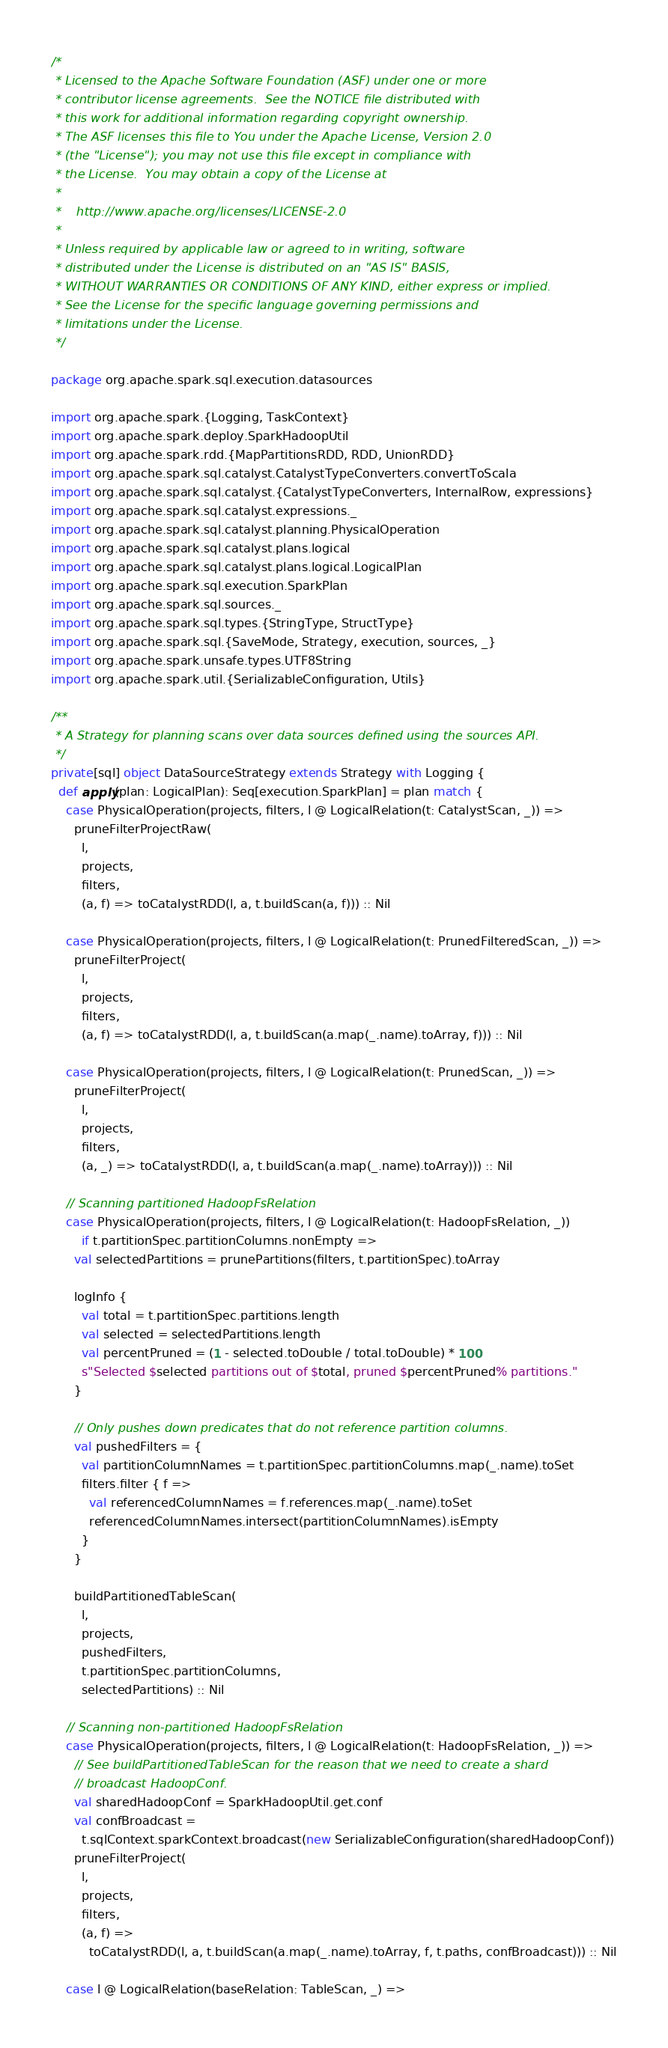<code> <loc_0><loc_0><loc_500><loc_500><_Scala_>/*
 * Licensed to the Apache Software Foundation (ASF) under one or more
 * contributor license agreements.  See the NOTICE file distributed with
 * this work for additional information regarding copyright ownership.
 * The ASF licenses this file to You under the Apache License, Version 2.0
 * (the "License"); you may not use this file except in compliance with
 * the License.  You may obtain a copy of the License at
 *
 *    http://www.apache.org/licenses/LICENSE-2.0
 *
 * Unless required by applicable law or agreed to in writing, software
 * distributed under the License is distributed on an "AS IS" BASIS,
 * WITHOUT WARRANTIES OR CONDITIONS OF ANY KIND, either express or implied.
 * See the License for the specific language governing permissions and
 * limitations under the License.
 */

package org.apache.spark.sql.execution.datasources

import org.apache.spark.{Logging, TaskContext}
import org.apache.spark.deploy.SparkHadoopUtil
import org.apache.spark.rdd.{MapPartitionsRDD, RDD, UnionRDD}
import org.apache.spark.sql.catalyst.CatalystTypeConverters.convertToScala
import org.apache.spark.sql.catalyst.{CatalystTypeConverters, InternalRow, expressions}
import org.apache.spark.sql.catalyst.expressions._
import org.apache.spark.sql.catalyst.planning.PhysicalOperation
import org.apache.spark.sql.catalyst.plans.logical
import org.apache.spark.sql.catalyst.plans.logical.LogicalPlan
import org.apache.spark.sql.execution.SparkPlan
import org.apache.spark.sql.sources._
import org.apache.spark.sql.types.{StringType, StructType}
import org.apache.spark.sql.{SaveMode, Strategy, execution, sources, _}
import org.apache.spark.unsafe.types.UTF8String
import org.apache.spark.util.{SerializableConfiguration, Utils}

/**
 * A Strategy for planning scans over data sources defined using the sources API.
 */
private[sql] object DataSourceStrategy extends Strategy with Logging {
  def apply(plan: LogicalPlan): Seq[execution.SparkPlan] = plan match {
    case PhysicalOperation(projects, filters, l @ LogicalRelation(t: CatalystScan, _)) =>
      pruneFilterProjectRaw(
        l,
        projects,
        filters,
        (a, f) => toCatalystRDD(l, a, t.buildScan(a, f))) :: Nil

    case PhysicalOperation(projects, filters, l @ LogicalRelation(t: PrunedFilteredScan, _)) =>
      pruneFilterProject(
        l,
        projects,
        filters,
        (a, f) => toCatalystRDD(l, a, t.buildScan(a.map(_.name).toArray, f))) :: Nil

    case PhysicalOperation(projects, filters, l @ LogicalRelation(t: PrunedScan, _)) =>
      pruneFilterProject(
        l,
        projects,
        filters,
        (a, _) => toCatalystRDD(l, a, t.buildScan(a.map(_.name).toArray))) :: Nil

    // Scanning partitioned HadoopFsRelation
    case PhysicalOperation(projects, filters, l @ LogicalRelation(t: HadoopFsRelation, _))
        if t.partitionSpec.partitionColumns.nonEmpty =>
      val selectedPartitions = prunePartitions(filters, t.partitionSpec).toArray

      logInfo {
        val total = t.partitionSpec.partitions.length
        val selected = selectedPartitions.length
        val percentPruned = (1 - selected.toDouble / total.toDouble) * 100
        s"Selected $selected partitions out of $total, pruned $percentPruned% partitions."
      }

      // Only pushes down predicates that do not reference partition columns.
      val pushedFilters = {
        val partitionColumnNames = t.partitionSpec.partitionColumns.map(_.name).toSet
        filters.filter { f =>
          val referencedColumnNames = f.references.map(_.name).toSet
          referencedColumnNames.intersect(partitionColumnNames).isEmpty
        }
      }

      buildPartitionedTableScan(
        l,
        projects,
        pushedFilters,
        t.partitionSpec.partitionColumns,
        selectedPartitions) :: Nil

    // Scanning non-partitioned HadoopFsRelation
    case PhysicalOperation(projects, filters, l @ LogicalRelation(t: HadoopFsRelation, _)) =>
      // See buildPartitionedTableScan for the reason that we need to create a shard
      // broadcast HadoopConf.
      val sharedHadoopConf = SparkHadoopUtil.get.conf
      val confBroadcast =
        t.sqlContext.sparkContext.broadcast(new SerializableConfiguration(sharedHadoopConf))
      pruneFilterProject(
        l,
        projects,
        filters,
        (a, f) =>
          toCatalystRDD(l, a, t.buildScan(a.map(_.name).toArray, f, t.paths, confBroadcast))) :: Nil

    case l @ LogicalRelation(baseRelation: TableScan, _) =></code> 